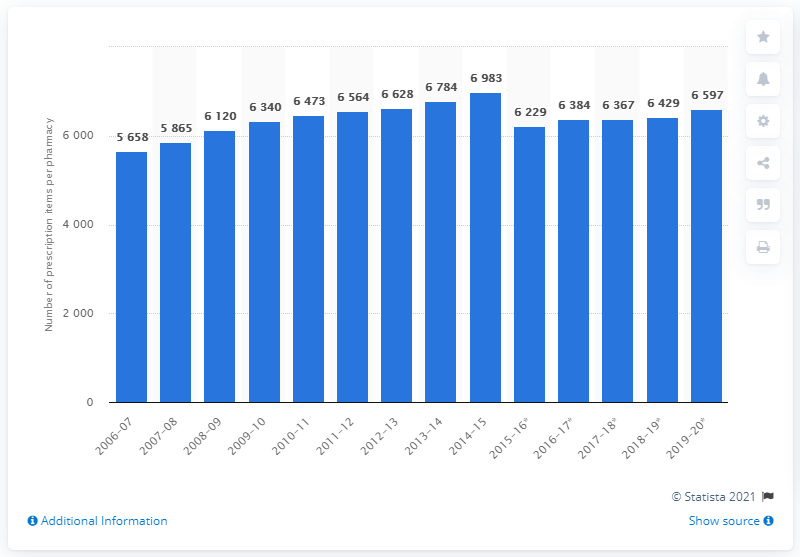Point out several critical features in this image. In the 2018/19 fiscal year, the average number of items dispensed per month per pharmacy was 6,597. In 2006/2007, the average number of items dispensed per month per pharmacy was 5,658. 